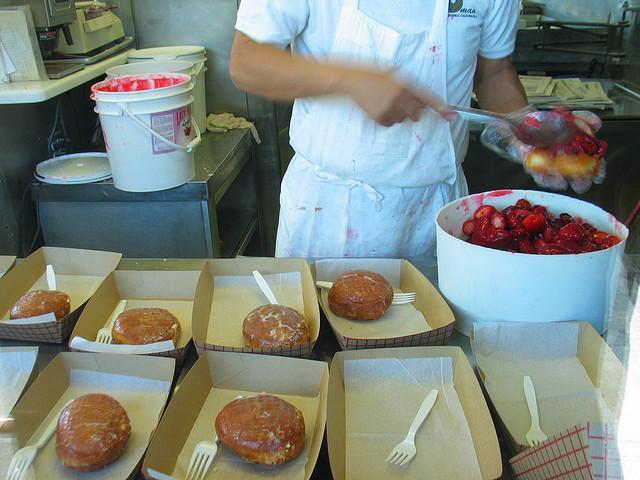How many spoons can you see?
Give a very brief answer. 1. How many donuts are visible?
Give a very brief answer. 6. How many buses are in the picture?
Give a very brief answer. 0. 